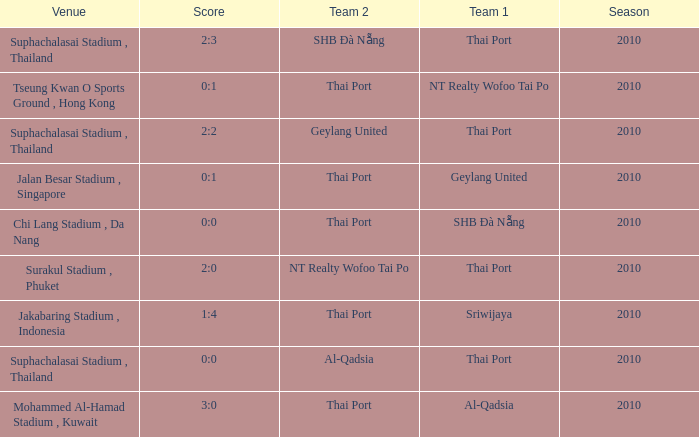Which venue was used for the game whose score was 2:3? Suphachalasai Stadium , Thailand. 